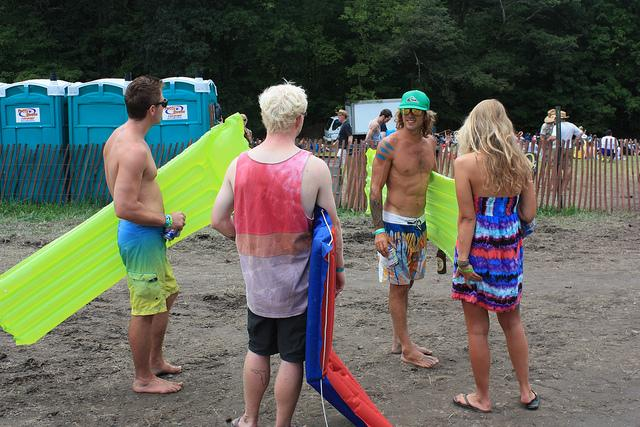Why is the guy's neck red? sunburn 